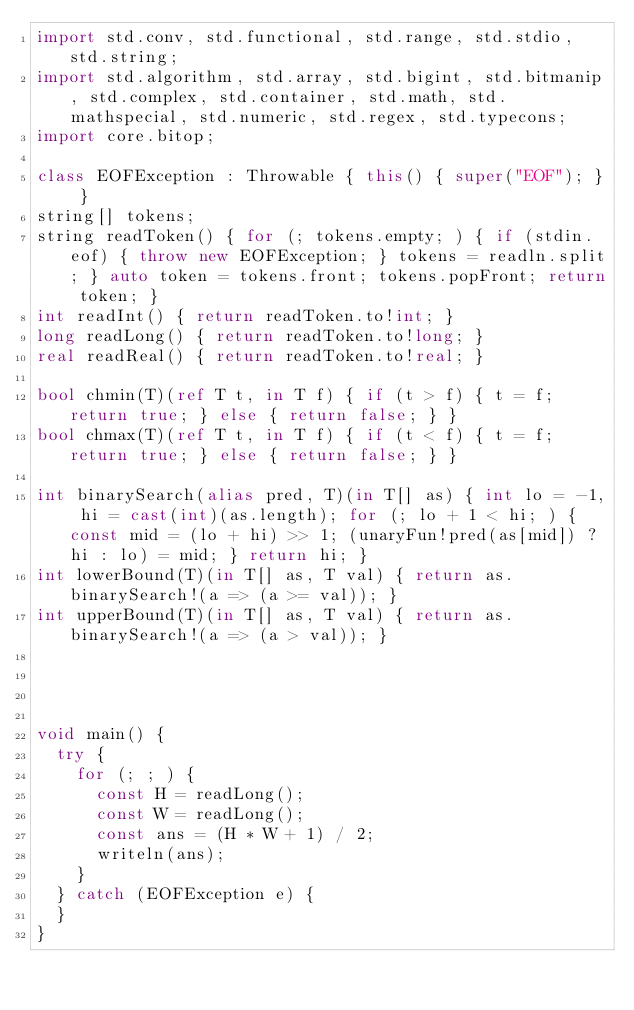Convert code to text. <code><loc_0><loc_0><loc_500><loc_500><_D_>import std.conv, std.functional, std.range, std.stdio, std.string;
import std.algorithm, std.array, std.bigint, std.bitmanip, std.complex, std.container, std.math, std.mathspecial, std.numeric, std.regex, std.typecons;
import core.bitop;

class EOFException : Throwable { this() { super("EOF"); } }
string[] tokens;
string readToken() { for (; tokens.empty; ) { if (stdin.eof) { throw new EOFException; } tokens = readln.split; } auto token = tokens.front; tokens.popFront; return token; }
int readInt() { return readToken.to!int; }
long readLong() { return readToken.to!long; }
real readReal() { return readToken.to!real; }

bool chmin(T)(ref T t, in T f) { if (t > f) { t = f; return true; } else { return false; } }
bool chmax(T)(ref T t, in T f) { if (t < f) { t = f; return true; } else { return false; } }

int binarySearch(alias pred, T)(in T[] as) { int lo = -1, hi = cast(int)(as.length); for (; lo + 1 < hi; ) { const mid = (lo + hi) >> 1; (unaryFun!pred(as[mid]) ? hi : lo) = mid; } return hi; }
int lowerBound(T)(in T[] as, T val) { return as.binarySearch!(a => (a >= val)); }
int upperBound(T)(in T[] as, T val) { return as.binarySearch!(a => (a > val)); }




void main() {
  try {
    for (; ; ) {
      const H = readLong();
      const W = readLong();
      const ans = (H * W + 1) / 2;
      writeln(ans);
    }
  } catch (EOFException e) {
  }
}
</code> 